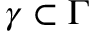Convert formula to latex. <formula><loc_0><loc_0><loc_500><loc_500>\gamma \subset \Gamma</formula> 